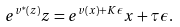<formula> <loc_0><loc_0><loc_500><loc_500>e ^ { v ^ { * } ( z ) } z = e ^ { v ( x ) + K \epsilon } x + \tau \epsilon .</formula> 